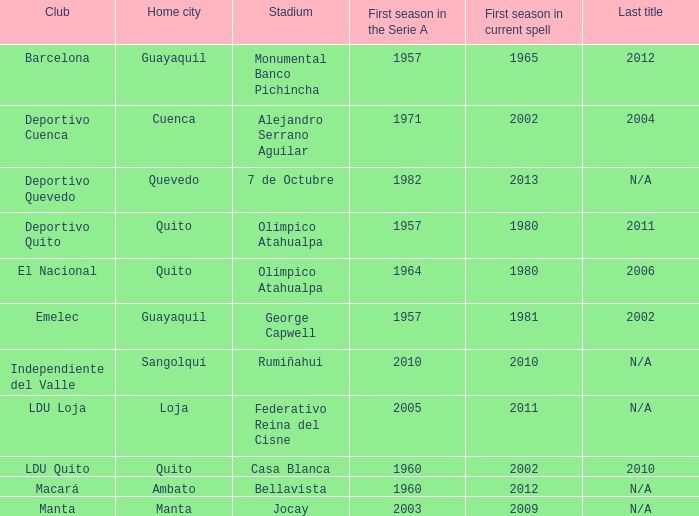Identify the association for quevedo. Deportivo Quevedo. 